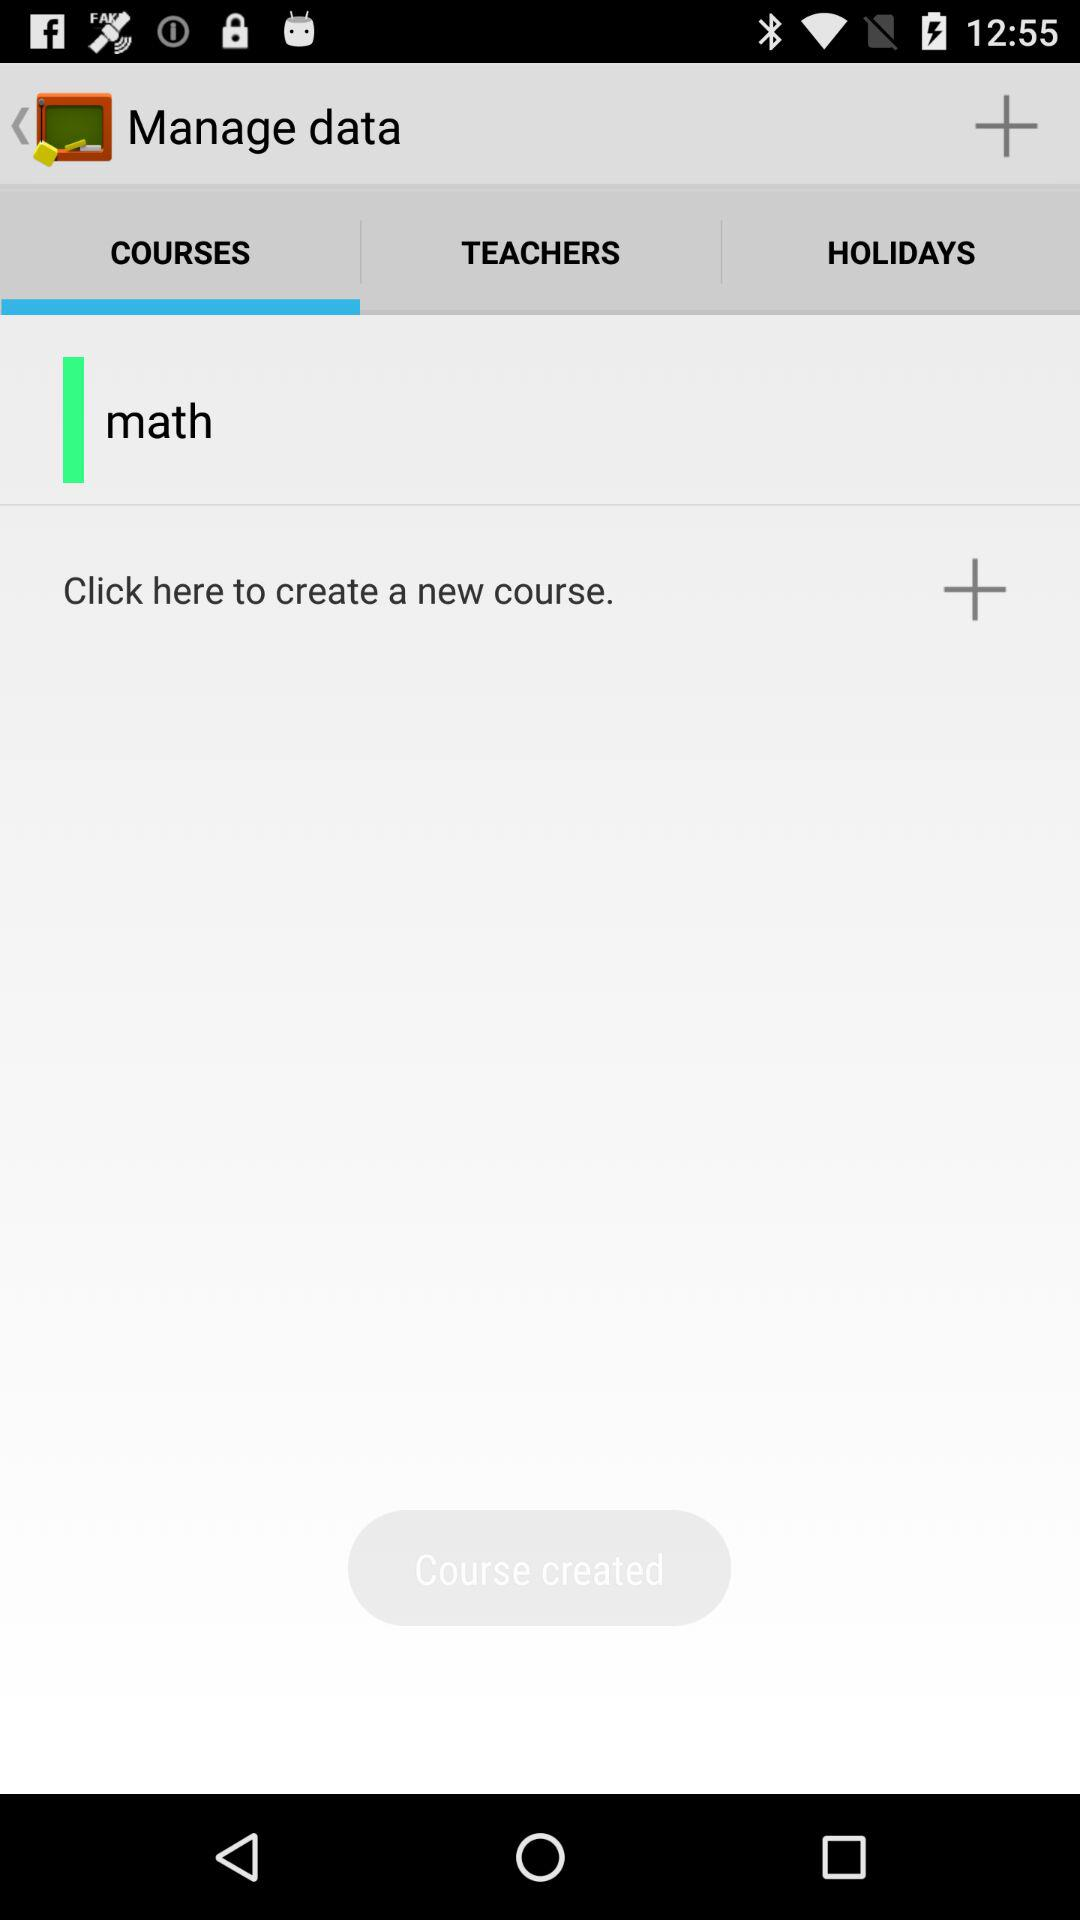How many courses are there?
Answer the question using a single word or phrase. 1 